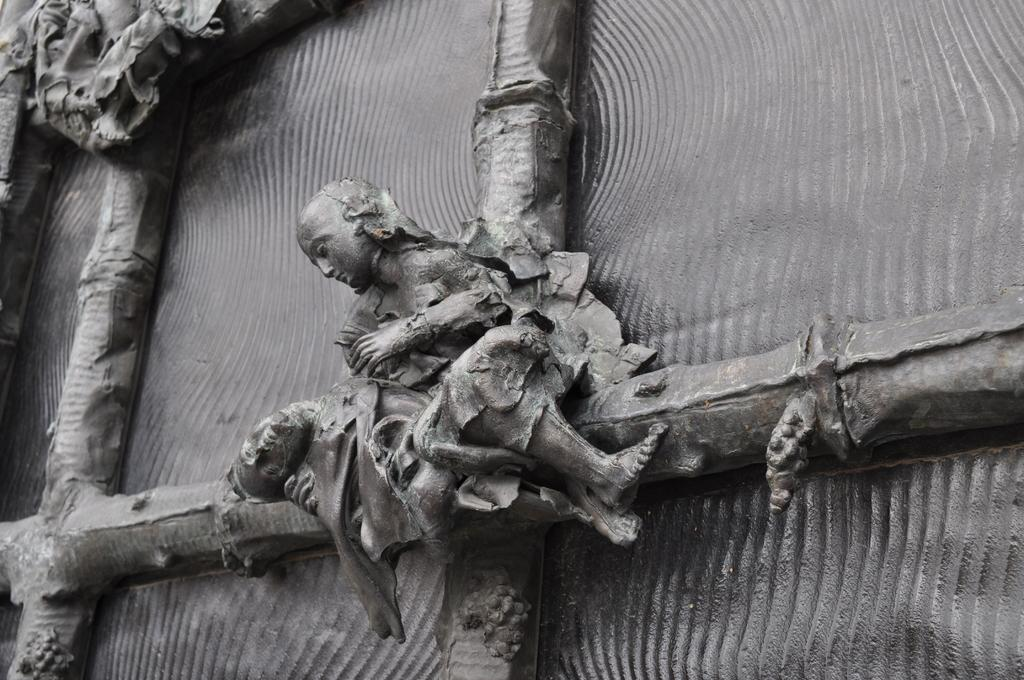What type of objects are in the foreground of the image? There are metal sculptures in the foreground of the image. What can be seen in the background of the image? There appears to be a metal sheet in the background of the image. What type of war is depicted in the image? There is no depiction of war in the image; it features metal sculptures and a metal sheet. Can you describe the body language of the metal sculptures in the image? The metal sculptures are inanimate objects and do not have body language. 